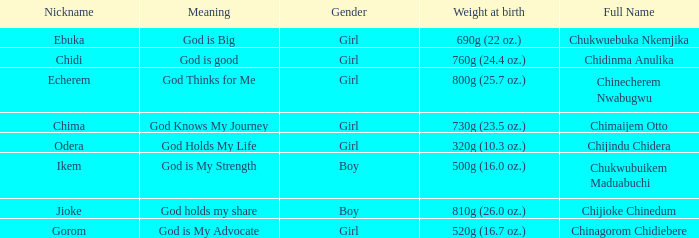What nickname has the meaning of God knows my journey? Chima. I'm looking to parse the entire table for insights. Could you assist me with that? {'header': ['Nickname', 'Meaning', 'Gender', 'Weight at birth', 'Full Name'], 'rows': [['Ebuka', 'God is Big', 'Girl', '690g (22 oz.)', 'Chukwuebuka Nkemjika'], ['Chidi', 'God is good', 'Girl', '760g (24.4 oz.)', 'Chidinma Anulika'], ['Echerem', 'God Thinks for Me', 'Girl', '800g (25.7 oz.)', 'Chinecherem Nwabugwu'], ['Chima', 'God Knows My Journey', 'Girl', '730g (23.5 oz.)', 'Chimaijem Otto'], ['Odera', 'God Holds My Life', 'Girl', '320g (10.3 oz.)', 'Chijindu Chidera'], ['Ikem', 'God is My Strength', 'Boy', '500g (16.0 oz.)', 'Chukwubuikem Maduabuchi'], ['Jioke', 'God holds my share', 'Boy', '810g (26.0 oz.)', 'Chijioke Chinedum'], ['Gorom', 'God is My Advocate', 'Girl', '520g (16.7 oz.)', 'Chinagorom Chidiebere']]} 